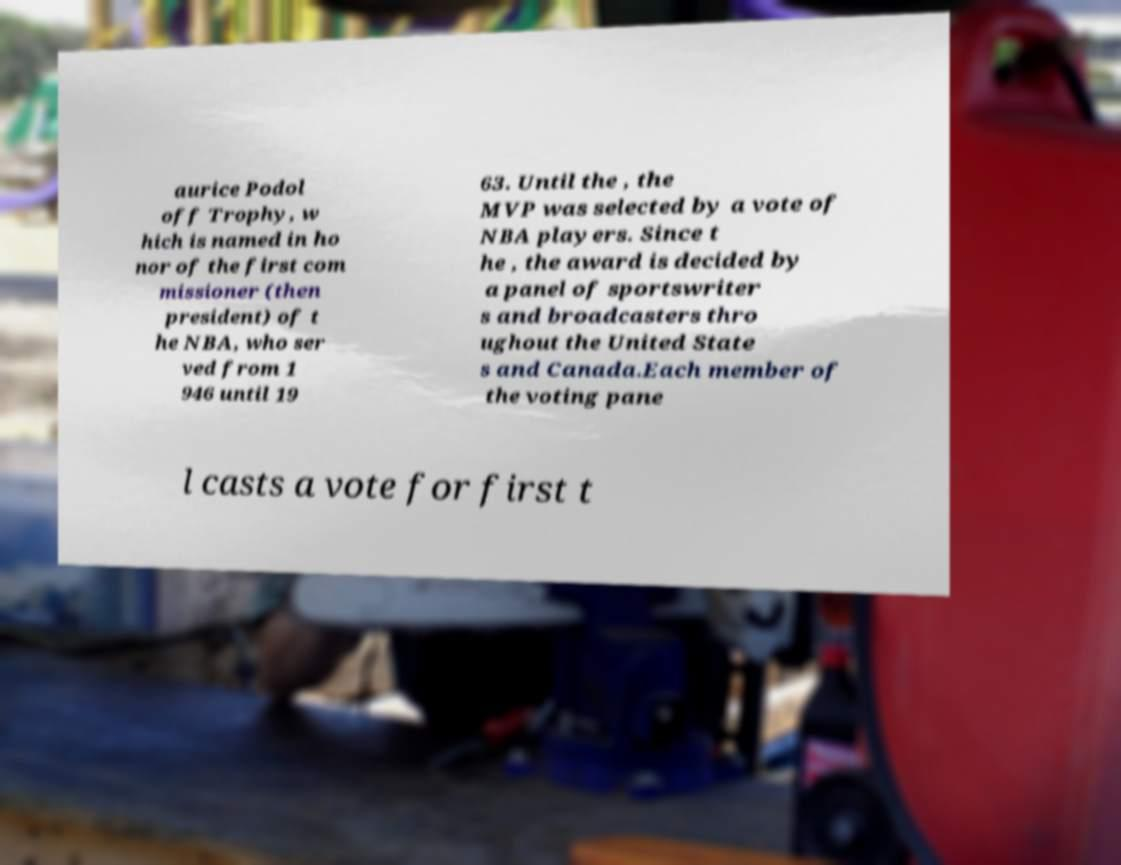What messages or text are displayed in this image? I need them in a readable, typed format. aurice Podol off Trophy, w hich is named in ho nor of the first com missioner (then president) of t he NBA, who ser ved from 1 946 until 19 63. Until the , the MVP was selected by a vote of NBA players. Since t he , the award is decided by a panel of sportswriter s and broadcasters thro ughout the United State s and Canada.Each member of the voting pane l casts a vote for first t 